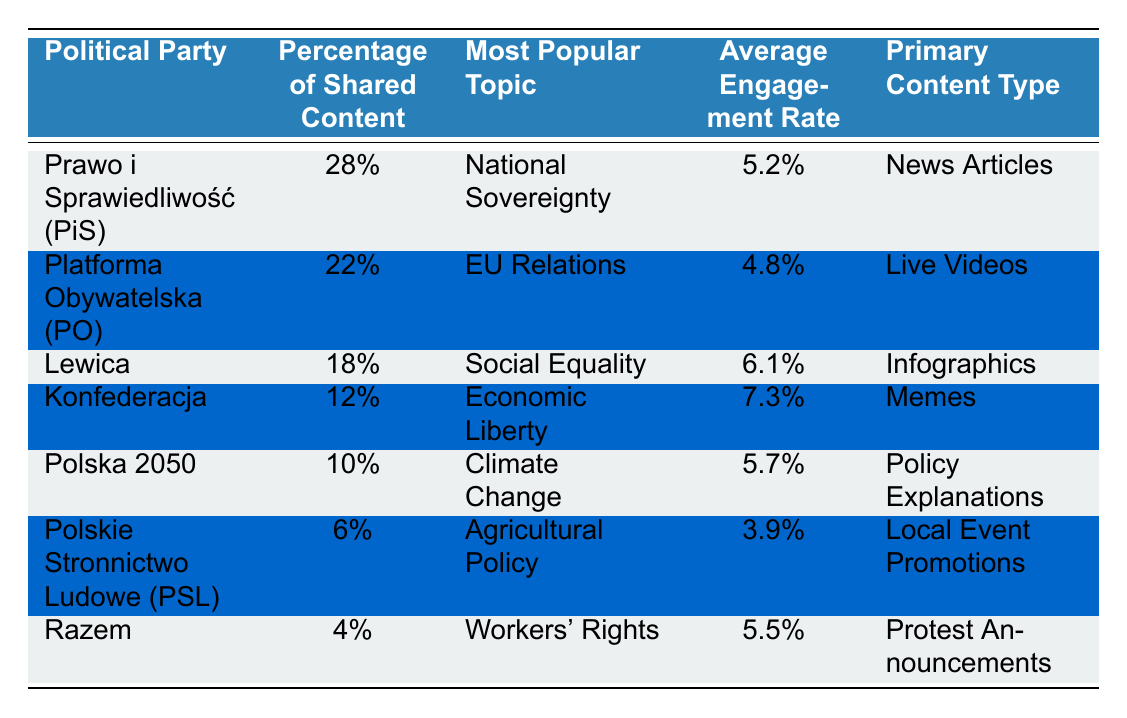What is the most popular topic shared by users relating to Platforma Obywatelska (PO)? According to the table, the most popular topic for Platforma Obywatelska (PO) is "EU Relations."
Answer: EU Relations Which political party has the highest average engagement rate? The table lists the average engagement rates, and Konfederacja has the highest at 7.3%.
Answer: Konfederacja What percentage of shared content does Razem account for? The table indicates that Razem accounts for 4% of shared content.
Answer: 4% What is the difference in the percentage of shared content between PiS and Polska 2050? PiS shares 28% of content while Polska 2050 shares 10%. The difference is 28% - 10% = 18%.
Answer: 18% Is the average engagement rate for Polskie Stronnictwo Ludowe (PSL) higher than that of Lewica? Polskie Stronnictwo Ludowe (PSL) has an average engagement rate of 3.9%, while Lewica's is 6.1%. Since 3.9% < 6.1%, the statement is false.
Answer: No Calculate the total percentage of shared content among all political parties listed. The total percentage is calculated by summing all the percentages: 28% + 22% + 18% + 12% + 10% + 6% + 4% = 100%.
Answer: 100% Which content type is most commonly associated with the Razem party? From the table, Razem primarily shares "Protest Announcements."
Answer: Protest Announcements Compare the primary content type of Konfederacja and Polska 2050. What are they? Konfederacja's primary content type is "Memes," while Polska 2050 shares "Policy Explanations."
Answer: Memes and Policy Explanations Does any political party have a higher shared content percentage than 20%? The table shows that both PiS (28%) and PO (22%) have percentages higher than 20%. Therefore, the answer is yes.
Answer: Yes What is the average engagement rate of the two parties with the lowest percentage of shared content? The two parties with the lowest percentages are Razem (4%) and PSL (6%). Their average engagement rate is (5.5% + 3.9%) / 2 = 4.7%.
Answer: 4.7% 